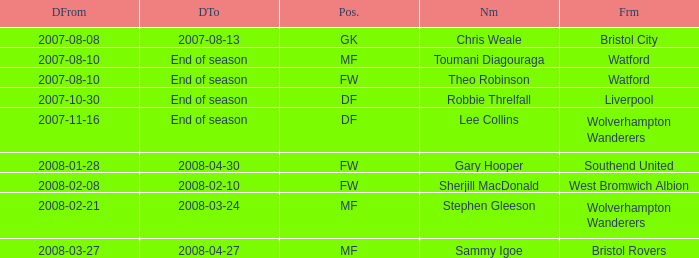What was the from for the Date From of 2007-08-08? Bristol City. 